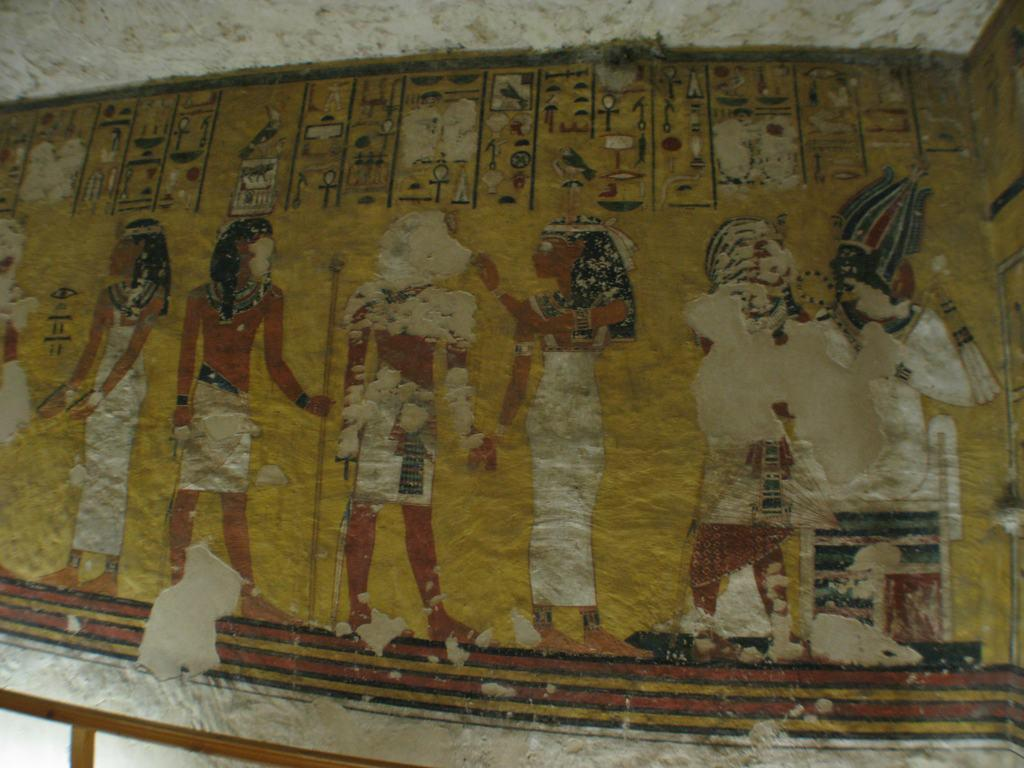What type of artwork can be seen on the wall in the image? There are paintings on the wall in the image. What riddle is depicted in the paintings on the wall? There is no riddle depicted in the paintings on the wall; they are simply paintings. 